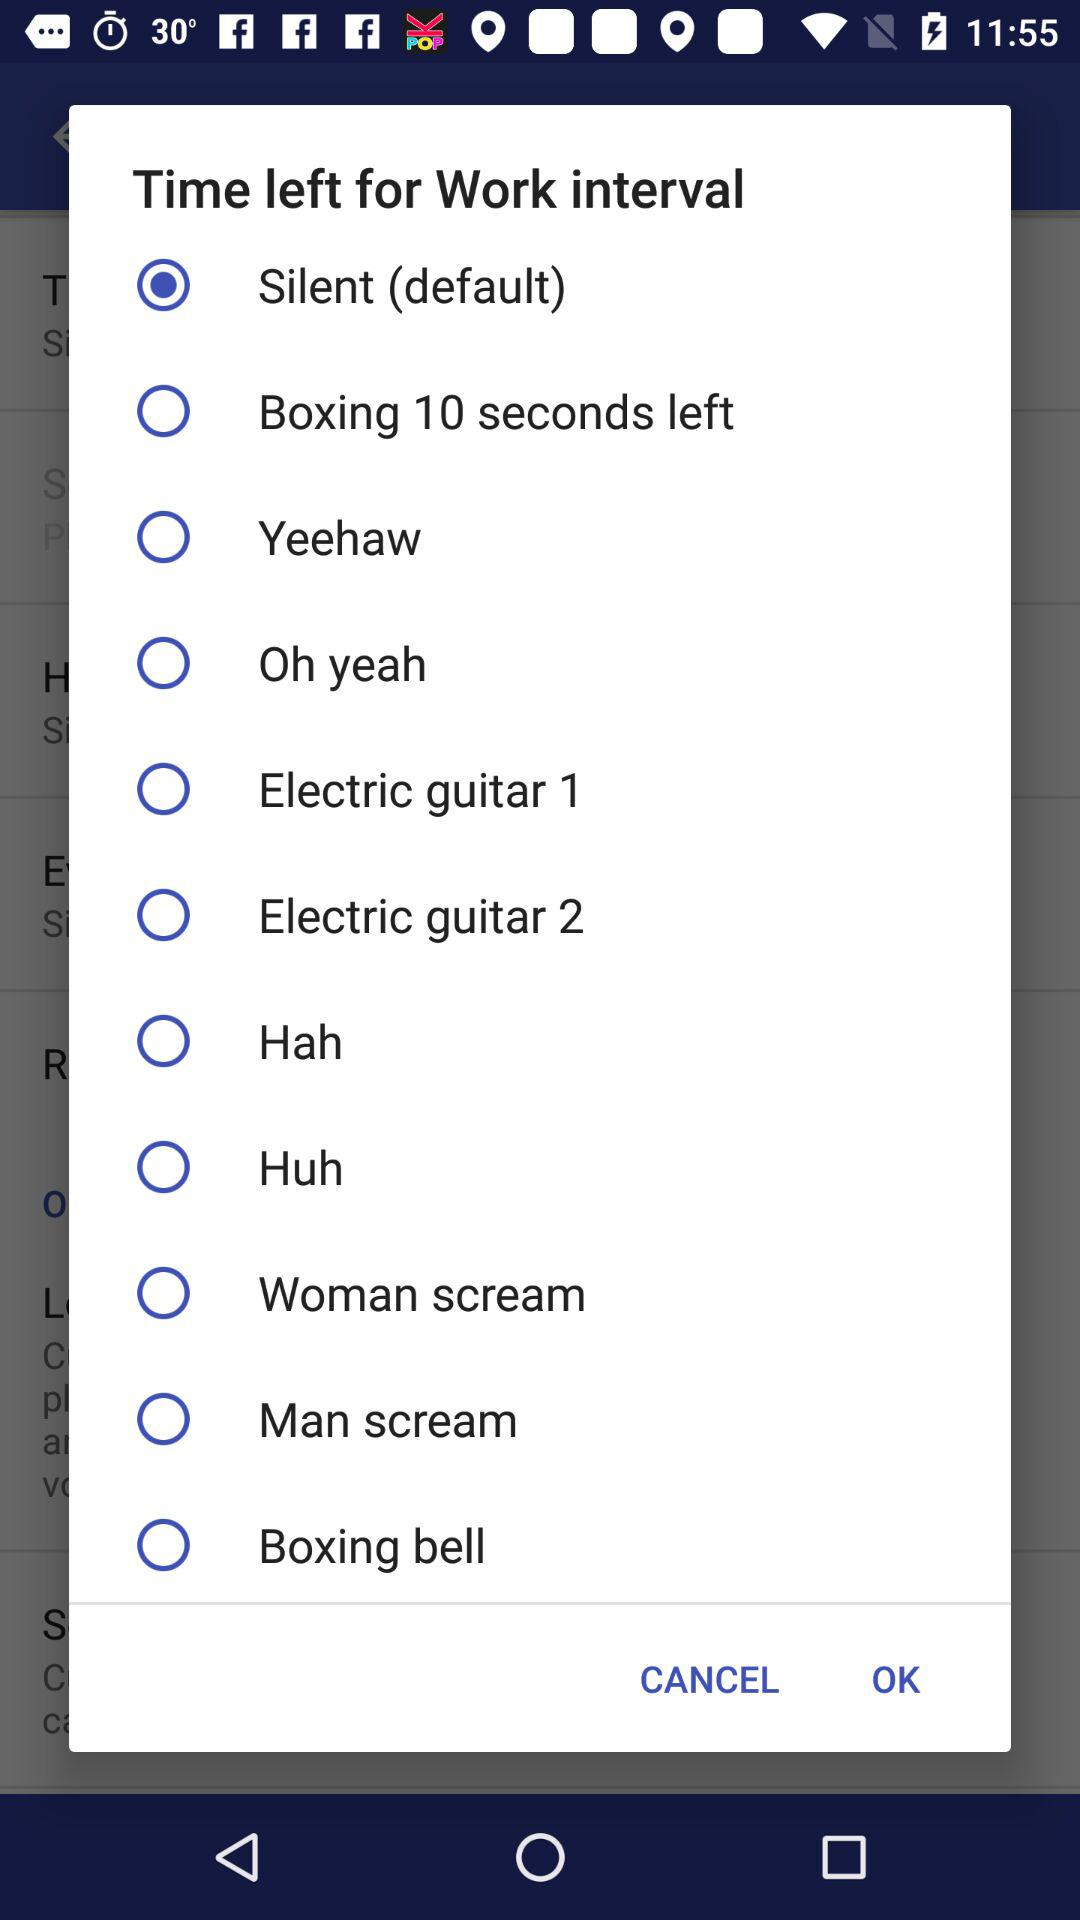What option has been selected? The selected option is "Silent (default)". 